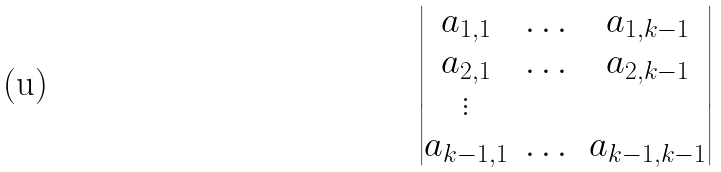<formula> <loc_0><loc_0><loc_500><loc_500>\begin{vmatrix} a _ { 1 , 1 } & \dots & a _ { 1 , k - 1 } \\ a _ { 2 , 1 } & \dots & a _ { 2 , k - 1 } \\ \vdots \\ a _ { k - 1 , 1 } & \dots & a _ { k - 1 , k - 1 } \end{vmatrix}</formula> 